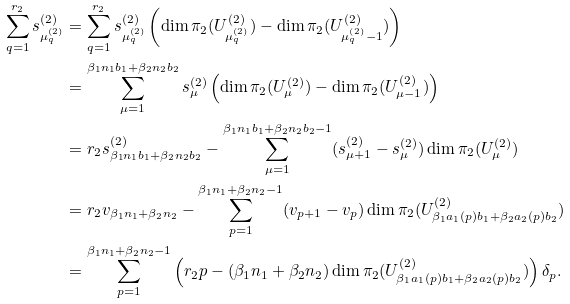Convert formula to latex. <formula><loc_0><loc_0><loc_500><loc_500>\sum _ { q = 1 } ^ { r _ { 2 } } s ^ { ( 2 ) } _ { \mu ^ { ( 2 ) } _ { q } } & = \sum _ { q = 1 } ^ { r _ { 2 } } s ^ { ( 2 ) } _ { \mu ^ { ( 2 ) } _ { q } } \left ( \dim \pi _ { 2 } ( U ^ { ( 2 ) } _ { \mu ^ { ( 2 ) } _ { q } } ) - \dim \pi _ { 2 } ( U ^ { ( 2 ) } _ { \mu ^ { ( 2 ) } _ { q } - 1 } ) \right ) \\ & = \sum _ { \mu = 1 } ^ { \beta _ { 1 } n _ { 1 } b _ { 1 } + \beta _ { 2 } n _ { 2 } b _ { 2 } } s ^ { ( 2 ) } _ { \mu } \left ( \dim \pi _ { 2 } ( U ^ { ( 2 ) } _ { \mu } ) - \dim \pi _ { 2 } ( U ^ { ( 2 ) } _ { \mu - 1 } ) \right ) \\ & = r _ { 2 } s ^ { ( 2 ) } _ { \beta _ { 1 } n _ { 1 } b _ { 1 } + \beta _ { 2 } n _ { 2 } b _ { 2 } } - \sum _ { \mu = 1 } ^ { \beta _ { 1 } n _ { 1 } b _ { 1 } + \beta _ { 2 } n _ { 2 } b _ { 2 } - 1 } ( s ^ { ( 2 ) } _ { \mu + 1 } - s ^ { ( 2 ) } _ { \mu } ) \dim \pi _ { 2 } ( U ^ { ( 2 ) } _ { \mu } ) \\ & = r _ { 2 } v _ { \beta _ { 1 } n _ { 1 } + \beta _ { 2 } n _ { 2 } } - \sum _ { p = 1 } ^ { \beta _ { 1 } n _ { 1 } + \beta _ { 2 } n _ { 2 } - 1 } ( v _ { p + 1 } - v _ { p } ) \dim \pi _ { 2 } ( U ^ { ( 2 ) } _ { \beta _ { 1 } a _ { 1 } ( p ) b _ { 1 } + \beta _ { 2 } a _ { 2 } ( p ) b _ { 2 } } ) \\ & = \sum _ { p = 1 } ^ { \beta _ { 1 } n _ { 1 } + \beta _ { 2 } n _ { 2 } - 1 } \left ( r _ { 2 } p - ( \beta _ { 1 } n _ { 1 } + \beta _ { 2 } n _ { 2 } ) \dim \pi _ { 2 } ( U ^ { ( 2 ) } _ { \beta _ { 1 } a _ { 1 } ( p ) b _ { 1 } + \beta _ { 2 } a _ { 2 } ( p ) b _ { 2 } } ) \right ) \delta _ { p } .</formula> 